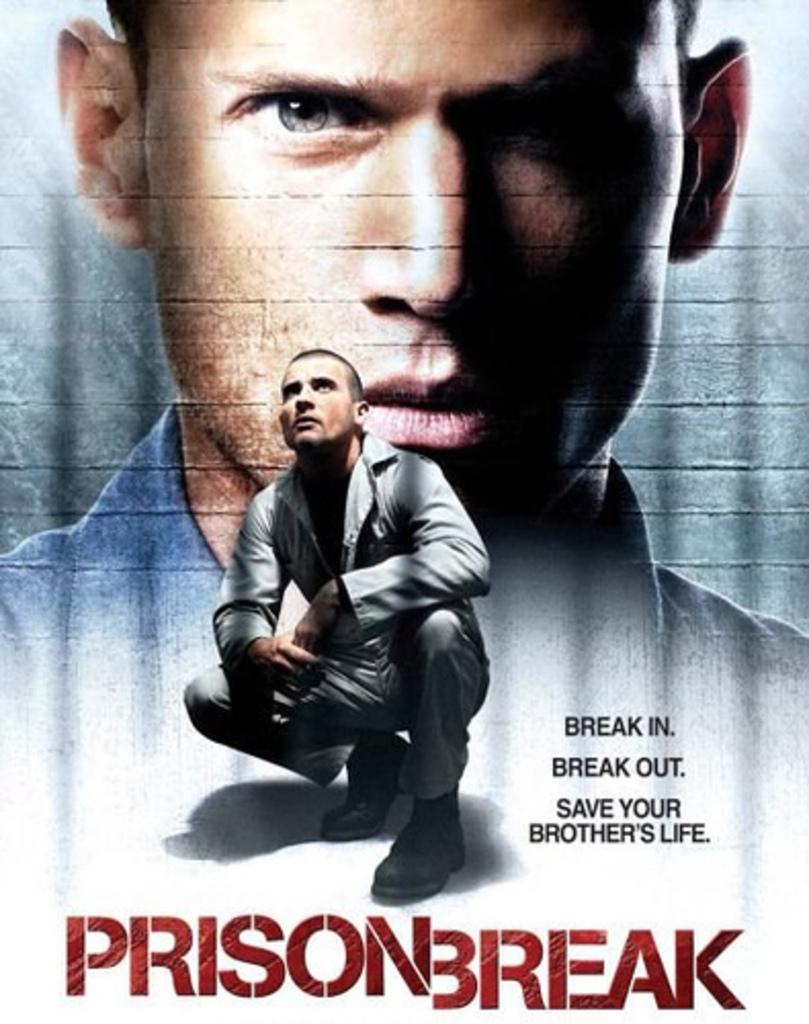Whose life is the protagonist trying to save?
Give a very brief answer. Your brother's. What s the title of the show shown on the poster?
Offer a terse response. Prison break. 